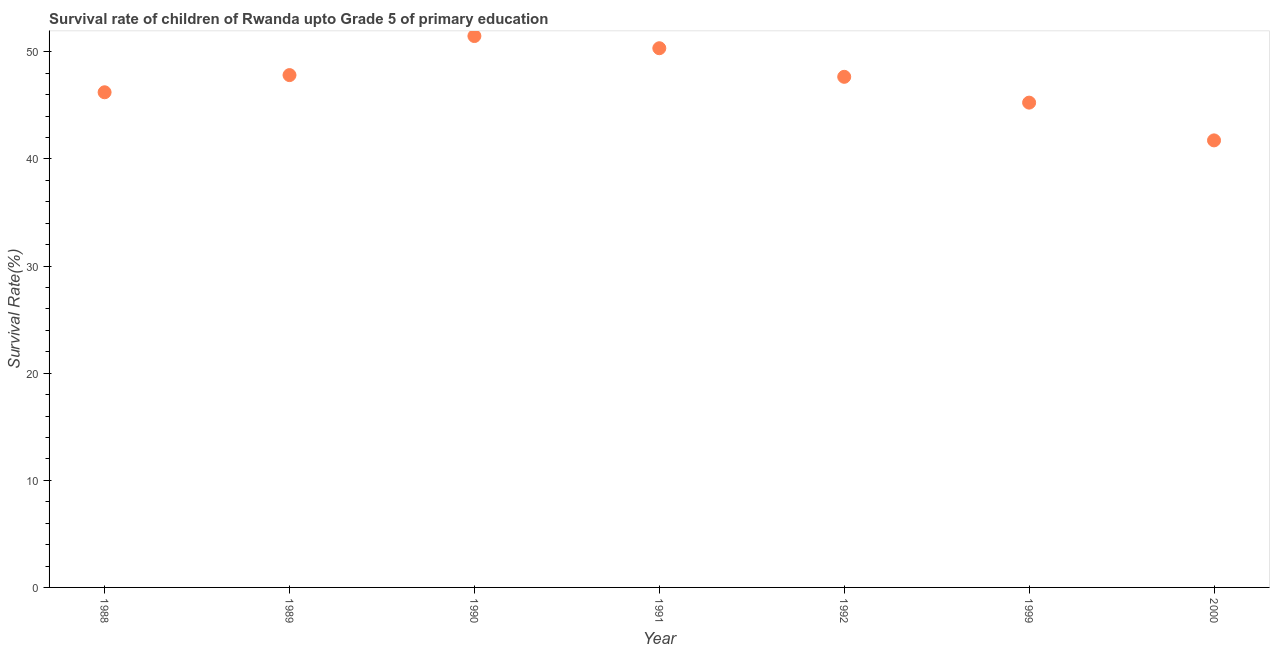What is the survival rate in 1991?
Your answer should be compact. 50.34. Across all years, what is the maximum survival rate?
Your answer should be very brief. 51.47. Across all years, what is the minimum survival rate?
Give a very brief answer. 41.73. In which year was the survival rate maximum?
Your answer should be very brief. 1990. What is the sum of the survival rate?
Ensure brevity in your answer.  330.52. What is the difference between the survival rate in 1989 and 1990?
Give a very brief answer. -3.65. What is the average survival rate per year?
Offer a very short reply. 47.22. What is the median survival rate?
Your response must be concise. 47.67. In how many years, is the survival rate greater than 46 %?
Give a very brief answer. 5. What is the ratio of the survival rate in 1989 to that in 1992?
Offer a very short reply. 1. What is the difference between the highest and the second highest survival rate?
Offer a very short reply. 1.14. What is the difference between the highest and the lowest survival rate?
Provide a succinct answer. 9.74. In how many years, is the survival rate greater than the average survival rate taken over all years?
Provide a short and direct response. 4. How many dotlines are there?
Provide a short and direct response. 1. How many years are there in the graph?
Offer a very short reply. 7. What is the difference between two consecutive major ticks on the Y-axis?
Offer a very short reply. 10. Are the values on the major ticks of Y-axis written in scientific E-notation?
Your answer should be compact. No. Does the graph contain any zero values?
Ensure brevity in your answer.  No. Does the graph contain grids?
Give a very brief answer. No. What is the title of the graph?
Keep it short and to the point. Survival rate of children of Rwanda upto Grade 5 of primary education. What is the label or title of the X-axis?
Provide a succinct answer. Year. What is the label or title of the Y-axis?
Offer a very short reply. Survival Rate(%). What is the Survival Rate(%) in 1988?
Ensure brevity in your answer.  46.22. What is the Survival Rate(%) in 1989?
Provide a short and direct response. 47.83. What is the Survival Rate(%) in 1990?
Ensure brevity in your answer.  51.47. What is the Survival Rate(%) in 1991?
Keep it short and to the point. 50.34. What is the Survival Rate(%) in 1992?
Your response must be concise. 47.67. What is the Survival Rate(%) in 1999?
Your response must be concise. 45.26. What is the Survival Rate(%) in 2000?
Give a very brief answer. 41.73. What is the difference between the Survival Rate(%) in 1988 and 1989?
Provide a succinct answer. -1.6. What is the difference between the Survival Rate(%) in 1988 and 1990?
Your answer should be very brief. -5.25. What is the difference between the Survival Rate(%) in 1988 and 1991?
Give a very brief answer. -4.11. What is the difference between the Survival Rate(%) in 1988 and 1992?
Make the answer very short. -1.44. What is the difference between the Survival Rate(%) in 1988 and 1999?
Your answer should be very brief. 0.97. What is the difference between the Survival Rate(%) in 1988 and 2000?
Offer a terse response. 4.49. What is the difference between the Survival Rate(%) in 1989 and 1990?
Your answer should be compact. -3.65. What is the difference between the Survival Rate(%) in 1989 and 1991?
Keep it short and to the point. -2.51. What is the difference between the Survival Rate(%) in 1989 and 1992?
Ensure brevity in your answer.  0.16. What is the difference between the Survival Rate(%) in 1989 and 1999?
Ensure brevity in your answer.  2.57. What is the difference between the Survival Rate(%) in 1989 and 2000?
Provide a succinct answer. 6.1. What is the difference between the Survival Rate(%) in 1990 and 1991?
Your answer should be very brief. 1.14. What is the difference between the Survival Rate(%) in 1990 and 1992?
Ensure brevity in your answer.  3.81. What is the difference between the Survival Rate(%) in 1990 and 1999?
Provide a short and direct response. 6.22. What is the difference between the Survival Rate(%) in 1990 and 2000?
Your answer should be compact. 9.74. What is the difference between the Survival Rate(%) in 1991 and 1992?
Your answer should be compact. 2.67. What is the difference between the Survival Rate(%) in 1991 and 1999?
Your answer should be very brief. 5.08. What is the difference between the Survival Rate(%) in 1991 and 2000?
Offer a terse response. 8.6. What is the difference between the Survival Rate(%) in 1992 and 1999?
Give a very brief answer. 2.41. What is the difference between the Survival Rate(%) in 1992 and 2000?
Offer a terse response. 5.93. What is the difference between the Survival Rate(%) in 1999 and 2000?
Offer a very short reply. 3.52. What is the ratio of the Survival Rate(%) in 1988 to that in 1990?
Your answer should be compact. 0.9. What is the ratio of the Survival Rate(%) in 1988 to that in 1991?
Ensure brevity in your answer.  0.92. What is the ratio of the Survival Rate(%) in 1988 to that in 1999?
Your response must be concise. 1.02. What is the ratio of the Survival Rate(%) in 1988 to that in 2000?
Your response must be concise. 1.11. What is the ratio of the Survival Rate(%) in 1989 to that in 1990?
Your answer should be compact. 0.93. What is the ratio of the Survival Rate(%) in 1989 to that in 1992?
Offer a terse response. 1. What is the ratio of the Survival Rate(%) in 1989 to that in 1999?
Your answer should be very brief. 1.06. What is the ratio of the Survival Rate(%) in 1989 to that in 2000?
Your answer should be compact. 1.15. What is the ratio of the Survival Rate(%) in 1990 to that in 1999?
Provide a succinct answer. 1.14. What is the ratio of the Survival Rate(%) in 1990 to that in 2000?
Your response must be concise. 1.23. What is the ratio of the Survival Rate(%) in 1991 to that in 1992?
Your answer should be very brief. 1.06. What is the ratio of the Survival Rate(%) in 1991 to that in 1999?
Make the answer very short. 1.11. What is the ratio of the Survival Rate(%) in 1991 to that in 2000?
Give a very brief answer. 1.21. What is the ratio of the Survival Rate(%) in 1992 to that in 1999?
Make the answer very short. 1.05. What is the ratio of the Survival Rate(%) in 1992 to that in 2000?
Keep it short and to the point. 1.14. What is the ratio of the Survival Rate(%) in 1999 to that in 2000?
Your answer should be compact. 1.08. 